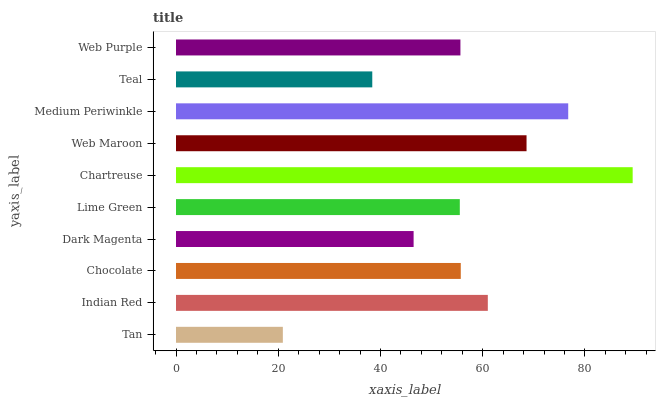Is Tan the minimum?
Answer yes or no. Yes. Is Chartreuse the maximum?
Answer yes or no. Yes. Is Indian Red the minimum?
Answer yes or no. No. Is Indian Red the maximum?
Answer yes or no. No. Is Indian Red greater than Tan?
Answer yes or no. Yes. Is Tan less than Indian Red?
Answer yes or no. Yes. Is Tan greater than Indian Red?
Answer yes or no. No. Is Indian Red less than Tan?
Answer yes or no. No. Is Chocolate the high median?
Answer yes or no. Yes. Is Web Purple the low median?
Answer yes or no. Yes. Is Web Purple the high median?
Answer yes or no. No. Is Tan the low median?
Answer yes or no. No. 